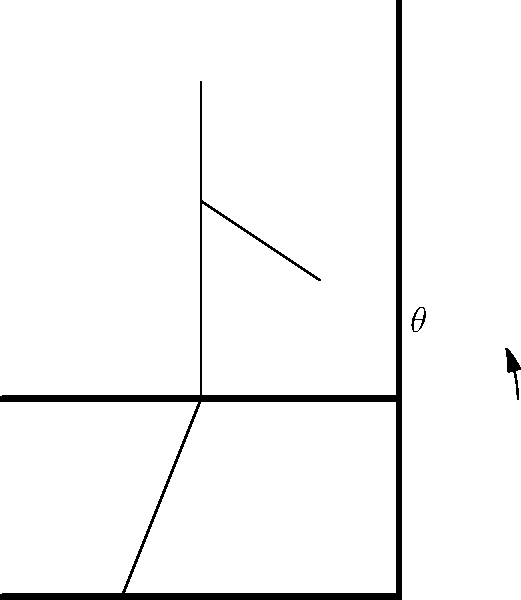In salon chair design, what is the recommended range for the backrest angle ($\theta$) to ensure optimal client comfort and minimize strain on the hairdresser during prolonged styling sessions? To determine the optimal backrest angle for salon chairs, we need to consider several biomechanical factors:

1. Spinal alignment: A slight recline helps maintain the natural curve of the spine.
2. Weight distribution: The angle affects how the client's weight is distributed across the seat and backrest.
3. Muscle relaxation: A proper angle allows for muscle relaxation without causing slouching.
4. Hairdresser's access: The angle should allow easy access for the hairdresser without causing strain.

Research in ergonomics suggests:

1. A completely upright position (90°) can cause discomfort and tension in the lower back.
2. A fully reclined position makes it difficult for the hairdresser to work effectively.
3. An angle between 100° and 110° from the horizontal provides a good balance.

The recommended range is typically:

$$100° \leq \theta \leq 110°$$

This range:
- Supports the natural curvature of the spine
- Distributes the client's weight evenly
- Allows for muscle relaxation
- Provides sufficient access for the hairdresser

Choosing an angle within this range helps ensure client comfort during long styling sessions while also considering the hairdresser's ergonomic needs.
Answer: 100° to 110° 